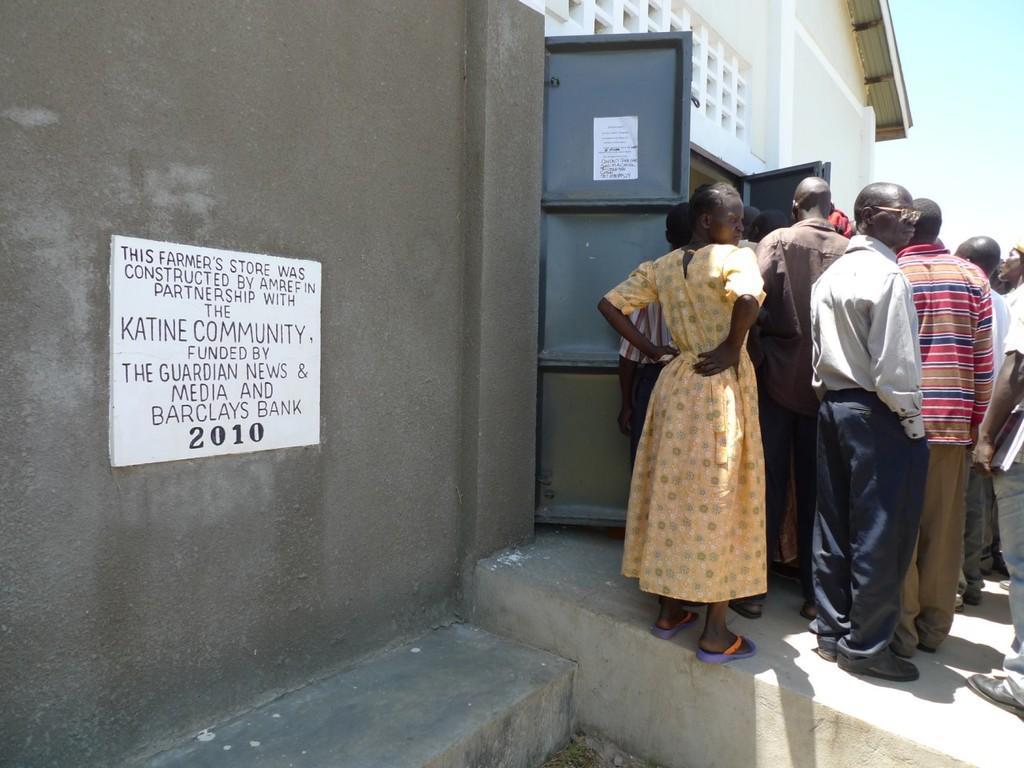In one or two sentences, can you explain what this image depicts? In this picture I can observe some people standing on the land. There are men and a woman on the right side. I can observe white color board on the wall on the left side. I can observe some text on the board. In the background there is sky. 